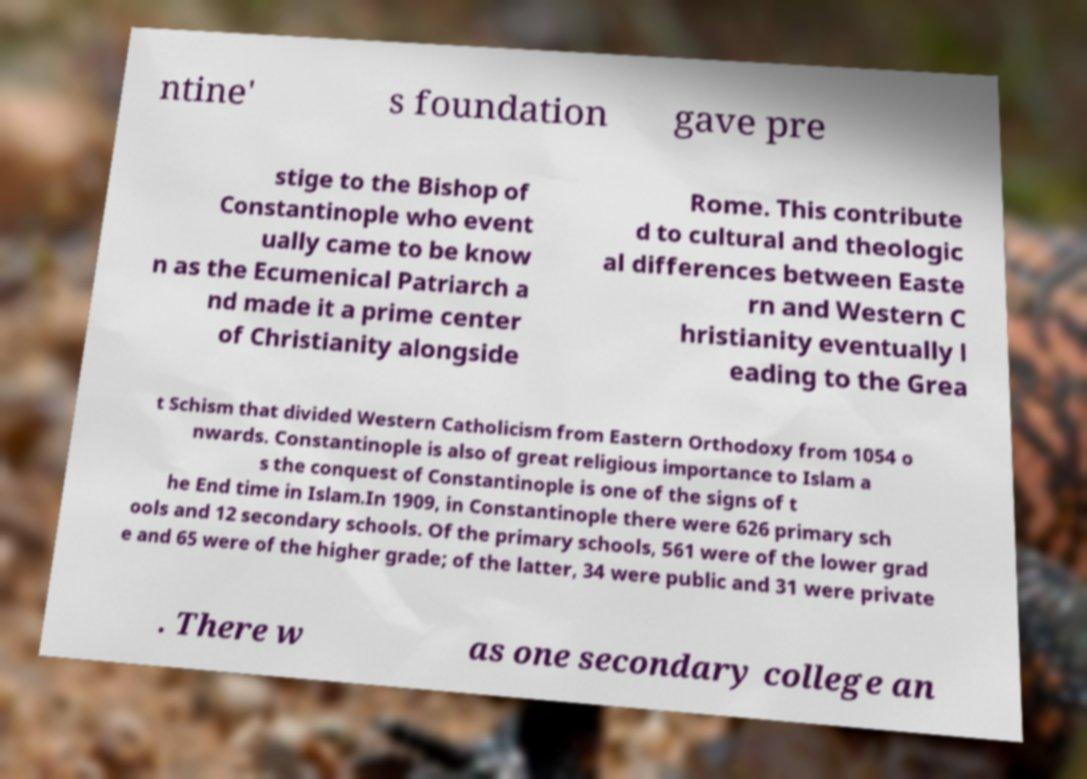Can you read and provide the text displayed in the image?This photo seems to have some interesting text. Can you extract and type it out for me? ntine' s foundation gave pre stige to the Bishop of Constantinople who event ually came to be know n as the Ecumenical Patriarch a nd made it a prime center of Christianity alongside Rome. This contribute d to cultural and theologic al differences between Easte rn and Western C hristianity eventually l eading to the Grea t Schism that divided Western Catholicism from Eastern Orthodoxy from 1054 o nwards. Constantinople is also of great religious importance to Islam a s the conquest of Constantinople is one of the signs of t he End time in Islam.In 1909, in Constantinople there were 626 primary sch ools and 12 secondary schools. Of the primary schools, 561 were of the lower grad e and 65 were of the higher grade; of the latter, 34 were public and 31 were private . There w as one secondary college an 